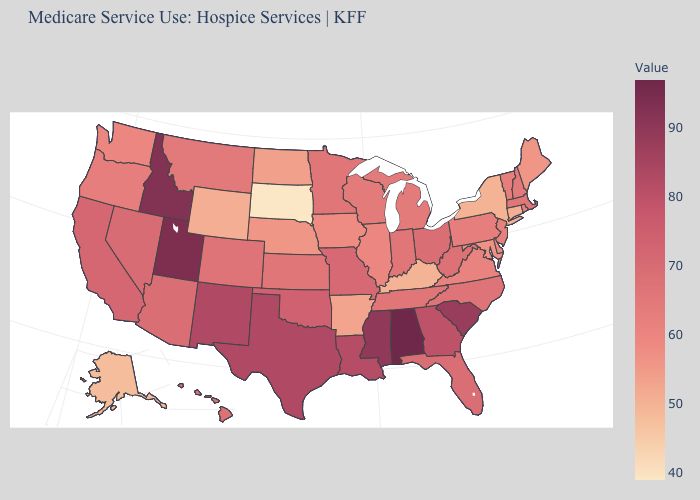Is the legend a continuous bar?
Give a very brief answer. Yes. Among the states that border North Carolina , which have the lowest value?
Quick response, please. Virginia. Which states hav the highest value in the MidWest?
Quick response, please. Missouri. Does Idaho have a higher value than Wyoming?
Quick response, please. Yes. Does the map have missing data?
Give a very brief answer. No. Among the states that border Maryland , does Virginia have the highest value?
Keep it brief. No. 